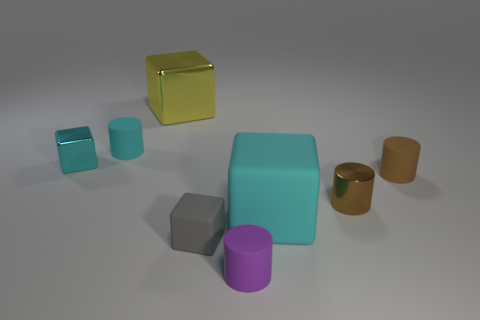Subtract all large cyan cubes. How many cubes are left? 3 Add 2 tiny purple rubber things. How many objects exist? 10 Subtract all purple cylinders. How many cylinders are left? 3 Add 5 gray objects. How many gray objects exist? 6 Subtract 0 yellow balls. How many objects are left? 8 Subtract 2 cylinders. How many cylinders are left? 2 Subtract all brown cylinders. Subtract all purple spheres. How many cylinders are left? 2 Subtract all yellow spheres. How many cyan cylinders are left? 1 Subtract all gray matte things. Subtract all yellow metal objects. How many objects are left? 6 Add 2 big metal objects. How many big metal objects are left? 3 